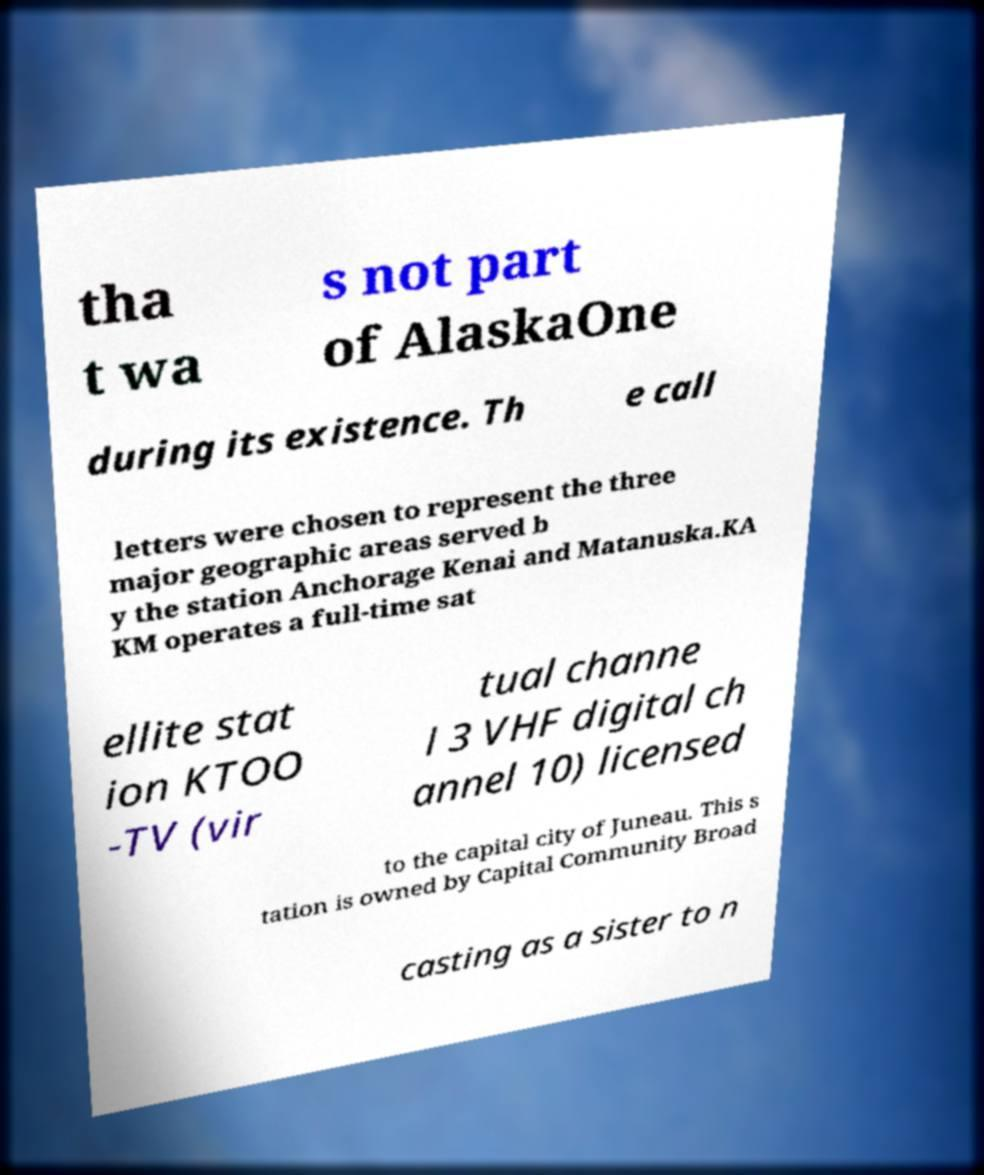Can you accurately transcribe the text from the provided image for me? tha t wa s not part of AlaskaOne during its existence. Th e call letters were chosen to represent the three major geographic areas served b y the station Anchorage Kenai and Matanuska.KA KM operates a full-time sat ellite stat ion KTOO -TV (vir tual channe l 3 VHF digital ch annel 10) licensed to the capital city of Juneau. This s tation is owned by Capital Community Broad casting as a sister to n 